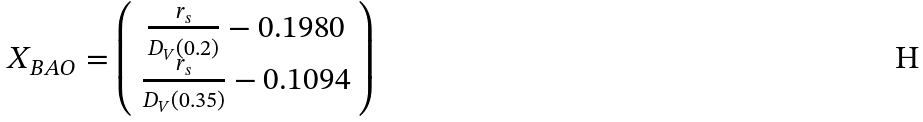<formula> <loc_0><loc_0><loc_500><loc_500>X _ { B A O } = \left ( \begin{array} { c } \frac { r _ { s } } { D _ { V } ( 0 . 2 ) } - 0 . 1 9 8 0 \\ \frac { r _ { s } } { D _ { V } ( 0 . 3 5 ) } - 0 . 1 0 9 4 \end{array} \right )</formula> 